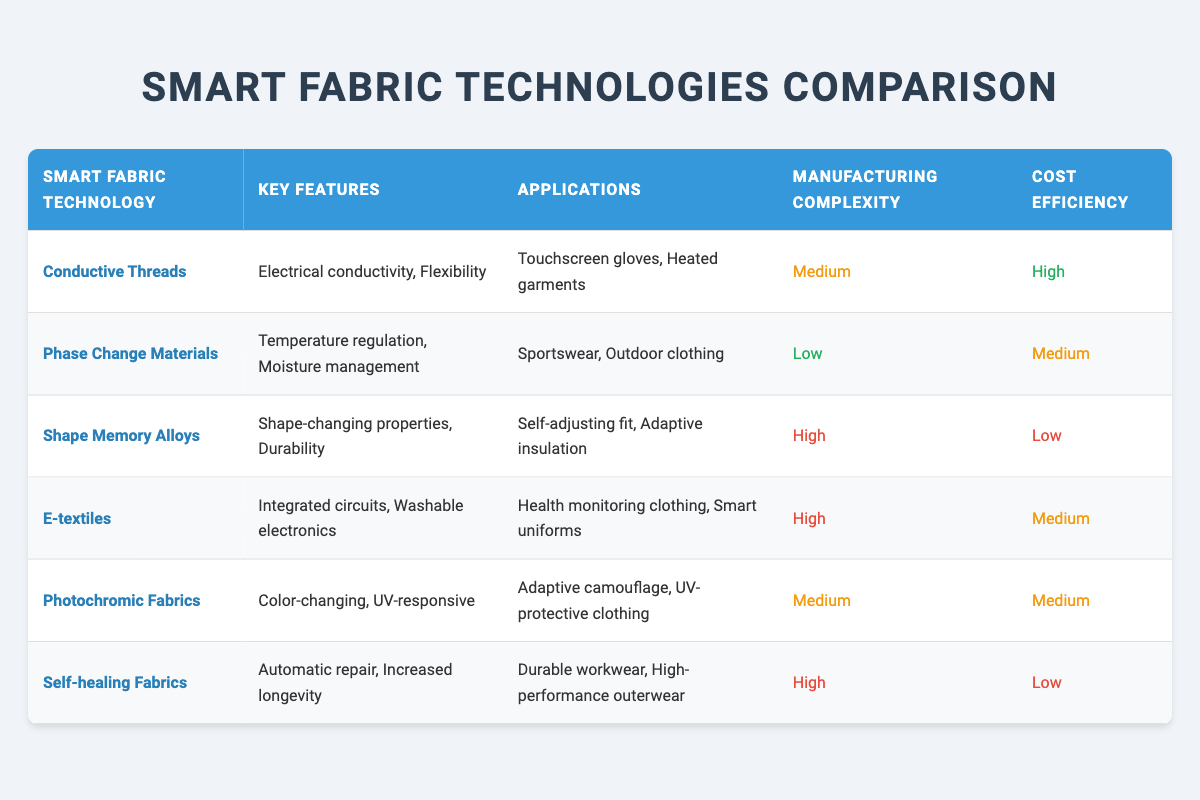What is the manufacturing complexity of E-textiles? The row for E-textiles shows the manufacturing complexity as "High". Therefore, it can be directly retrieved from the table.
Answer: High Which smart fabric technology has the lowest cost efficiency? Among the provided technologies, "Shape Memory Alloys" and "Self-healing Fabrics" both have a cost efficiency labeled as "Low". However, since we only consider the lowest, we can also refer to just one of them, thus "Shape Memory Alloys" has the lowest cost efficiency as it is mentioned first in the table.
Answer: Shape Memory Alloys Are Phase Change Materials used in outdoor clothing? The applications listed under Phase Change Materials confirm that they are utilized in "Outdoor clothing." Thus, the fact is verified from the table.
Answer: Yes How many smart fabric technologies have medium manufacturing complexity? By examining the complexity column, we find that both "Conductive Threads" and "Photochromic Fabrics" are marked as "Medium". Summing these up gives us a total of 2 technologies.
Answer: 2 Which smart fabric technology has temperature regulation as a key feature? Referring to the key features of each technology, "Phase Change Materials" highlights "Temperature regulation" as one of its features. This information can be extracted from the table directly.
Answer: Phase Change Materials How many applications are featured under self-healing fabrics? The table shows a single application for "Self-healing Fabrics," which is "Durable workwear, High-performance outerwear." Therefore, it lists them together as one entry under applications. Hence, the count remains at 1 for distinct applications.
Answer: 1 Which smart fabric technology offers the most cost-efficient solution? Judging from the cost efficiency, "Shape Memory Alloys" and "Self-healing Fabrics" both stand out as "Low" cost efficiency. However, when considering the title of highest cost efficiency, "Conductive Threads" are recognized as "High", thus indicating the most cost-effective solution amongst the technologies mentioned.
Answer: Conductive Threads How do the manufacturing complexities of E-textiles and Photochromic Fabrics compare? Both E-textiles and Photochromic Fabrics present a varying degree of complexity. E-textiles are under the "High" category whereas Photochromic Fabrics fall under "Medium". Comparing them shows that E-textiles are more complex to manufacture than Photochromic Fabrics.
Answer: E-textiles are more complex 